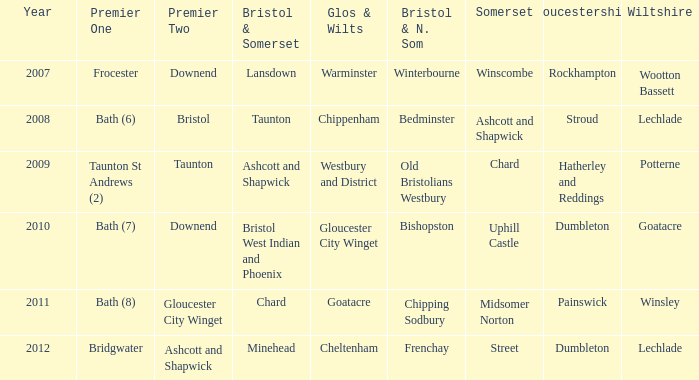What is the somerset for the year 2009? Chard. 